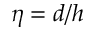<formula> <loc_0><loc_0><loc_500><loc_500>\eta = d / h</formula> 